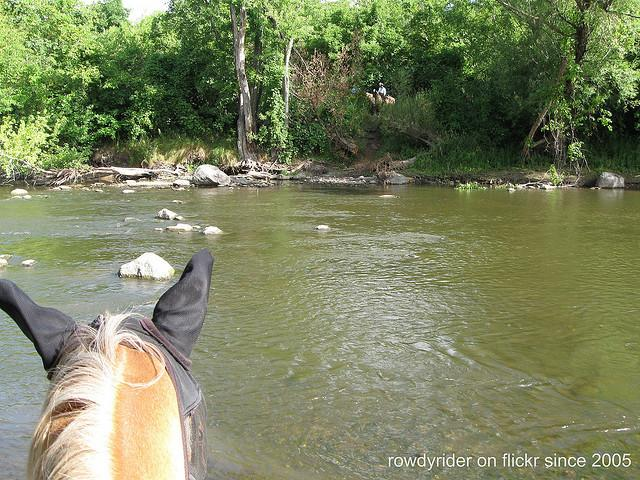What is the maximum speed of this type of animal in miles per hour?

Choices:
A) 15
B) 25
C) 40
D) 55 55 